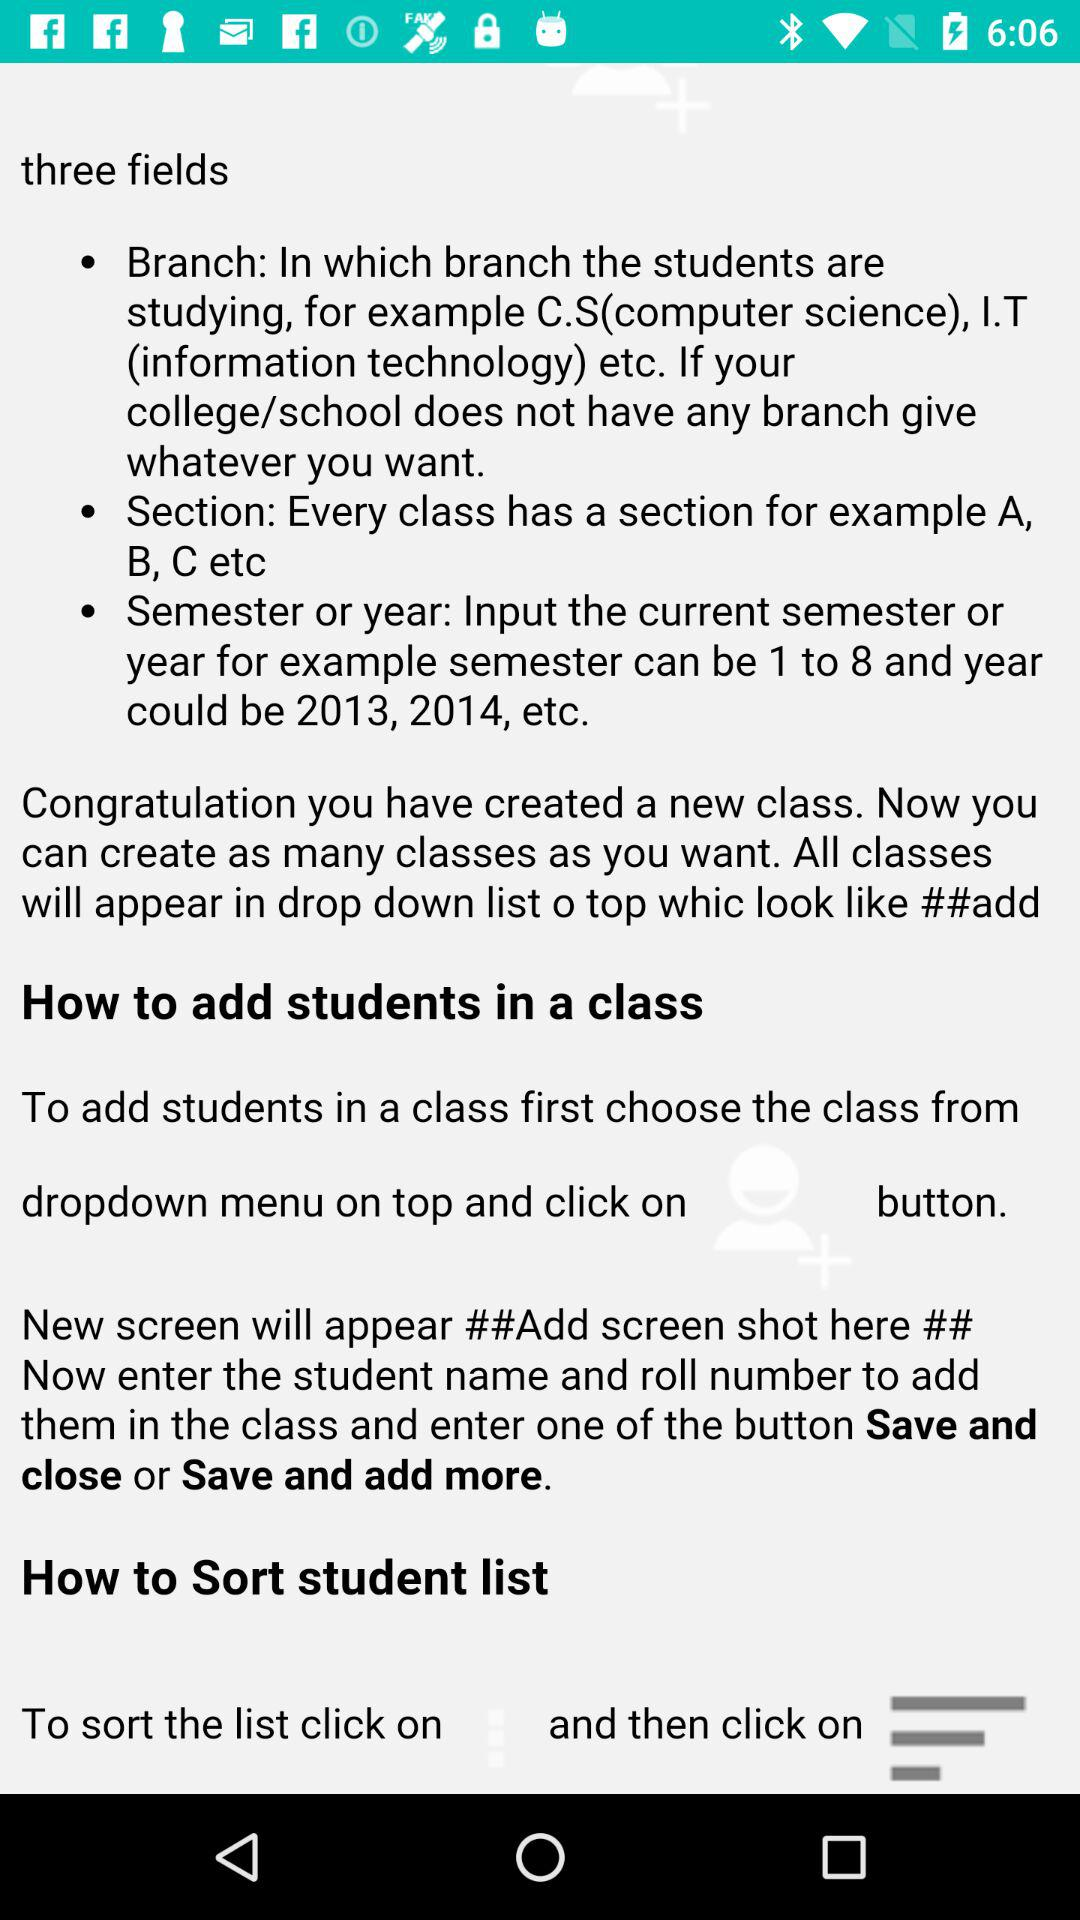Which input fields need to be entered to add students in class?
When the provided information is insufficient, respond with <no answer>. <no answer> 